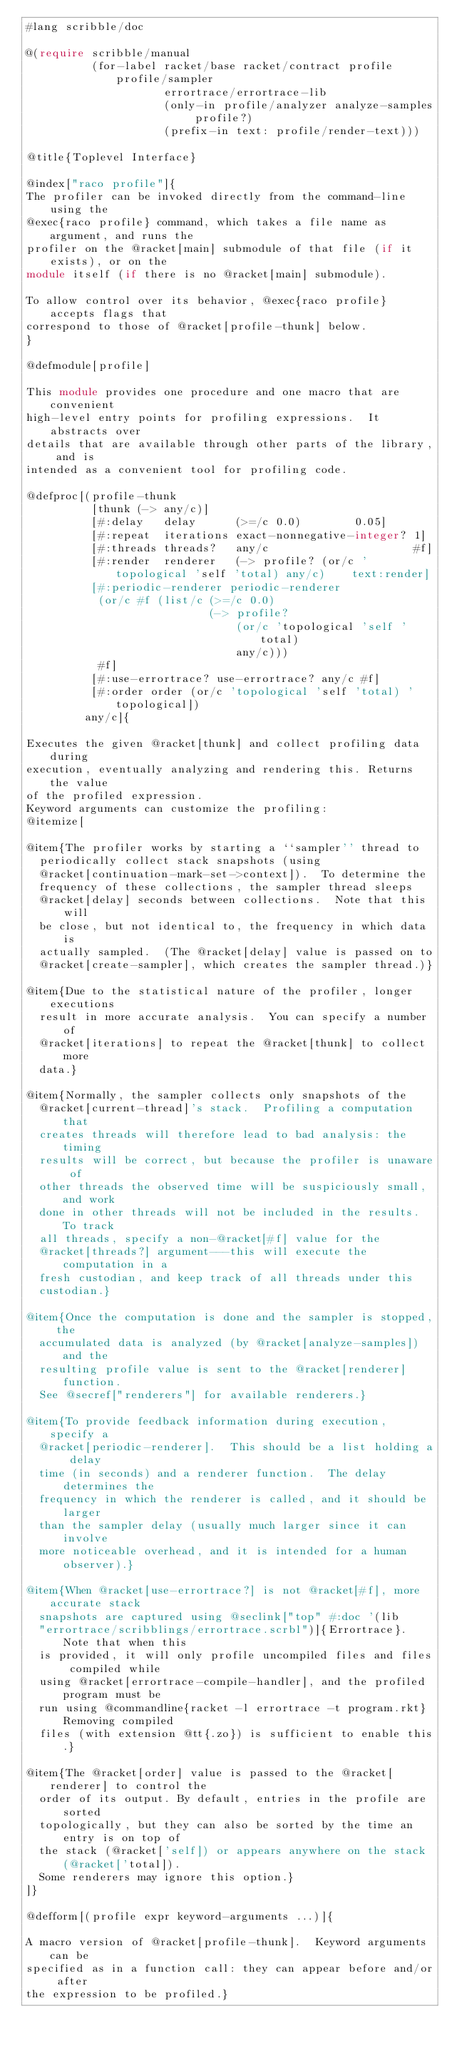Convert code to text. <code><loc_0><loc_0><loc_500><loc_500><_Racket_>#lang scribble/doc

@(require scribble/manual
          (for-label racket/base racket/contract profile profile/sampler
                     errortrace/errortrace-lib
                     (only-in profile/analyzer analyze-samples profile?)
                     (prefix-in text: profile/render-text)))

@title{Toplevel Interface}

@index["raco profile"]{
The profiler can be invoked directly from the command-line using the
@exec{raco profile} command, which takes a file name as argument, and runs the
profiler on the @racket[main] submodule of that file (if it exists), or on the
module itself (if there is no @racket[main] submodule).

To allow control over its behavior, @exec{raco profile} accepts flags that
correspond to those of @racket[profile-thunk] below.
}

@defmodule[profile]

This module provides one procedure and one macro that are convenient
high-level entry points for profiling expressions.  It abstracts over
details that are available through other parts of the library, and is
intended as a convenient tool for profiling code.

@defproc[(profile-thunk
          [thunk (-> any/c)]
          [#:delay   delay      (>=/c 0.0)        0.05]
          [#:repeat  iterations exact-nonnegative-integer? 1]
          [#:threads threads?   any/c                      #f]
          [#:render  renderer   (-> profile? (or/c 'topological 'self 'total) any/c)    text:render]
          [#:periodic-renderer periodic-renderer
           (or/c #f (list/c (>=/c 0.0)
                            (-> profile?
                                (or/c 'topological 'self 'total)
                                any/c)))
           #f]
          [#:use-errortrace? use-errortrace? any/c #f]
          [#:order order (or/c 'topological 'self 'total) 'topological])
         any/c]{

Executes the given @racket[thunk] and collect profiling data during
execution, eventually analyzing and rendering this. Returns the value
of the profiled expression.
Keyword arguments can customize the profiling:
@itemize[

@item{The profiler works by starting a ``sampler'' thread to
  periodically collect stack snapshots (using
  @racket[continuation-mark-set->context]).  To determine the
  frequency of these collections, the sampler thread sleeps
  @racket[delay] seconds between collections.  Note that this will
  be close, but not identical to, the frequency in which data is
  actually sampled.  (The @racket[delay] value is passed on to
  @racket[create-sampler], which creates the sampler thread.)}

@item{Due to the statistical nature of the profiler, longer executions
  result in more accurate analysis.  You can specify a number of
  @racket[iterations] to repeat the @racket[thunk] to collect more
  data.}

@item{Normally, the sampler collects only snapshots of the
  @racket[current-thread]'s stack.  Profiling a computation that
  creates threads will therefore lead to bad analysis: the timing
  results will be correct, but because the profiler is unaware of
  other threads the observed time will be suspiciously small, and work
  done in other threads will not be included in the results.  To track
  all threads, specify a non-@racket[#f] value for the
  @racket[threads?] argument---this will execute the computation in a
  fresh custodian, and keep track of all threads under this
  custodian.}

@item{Once the computation is done and the sampler is stopped, the
  accumulated data is analyzed (by @racket[analyze-samples]) and the
  resulting profile value is sent to the @racket[renderer] function.
  See @secref["renderers"] for available renderers.}

@item{To provide feedback information during execution, specify a
  @racket[periodic-renderer].  This should be a list holding a delay
  time (in seconds) and a renderer function.  The delay determines the
  frequency in which the renderer is called, and it should be larger
  than the sampler delay (usually much larger since it can involve
  more noticeable overhead, and it is intended for a human observer).}

@item{When @racket[use-errortrace?] is not @racket[#f], more accurate stack
  snapshots are captured using @seclink["top" #:doc '(lib
  "errortrace/scribblings/errortrace.scrbl")]{Errortrace}. Note that when this
  is provided, it will only profile uncompiled files and files compiled while
  using @racket[errortrace-compile-handler], and the profiled program must be
  run using @commandline{racket -l errortrace -t program.rkt} Removing compiled
  files (with extension @tt{.zo}) is sufficient to enable this.}

@item{The @racket[order] value is passed to the @racket[renderer] to control the
  order of its output. By default, entries in the profile are sorted
  topologically, but they can also be sorted by the time an entry is on top of
  the stack (@racket['self]) or appears anywhere on the stack (@racket['total]).
  Some renderers may ignore this option.}
]}

@defform[(profile expr keyword-arguments ...)]{

A macro version of @racket[profile-thunk].  Keyword arguments can be
specified as in a function call: they can appear before and/or after
the expression to be profiled.}
</code> 